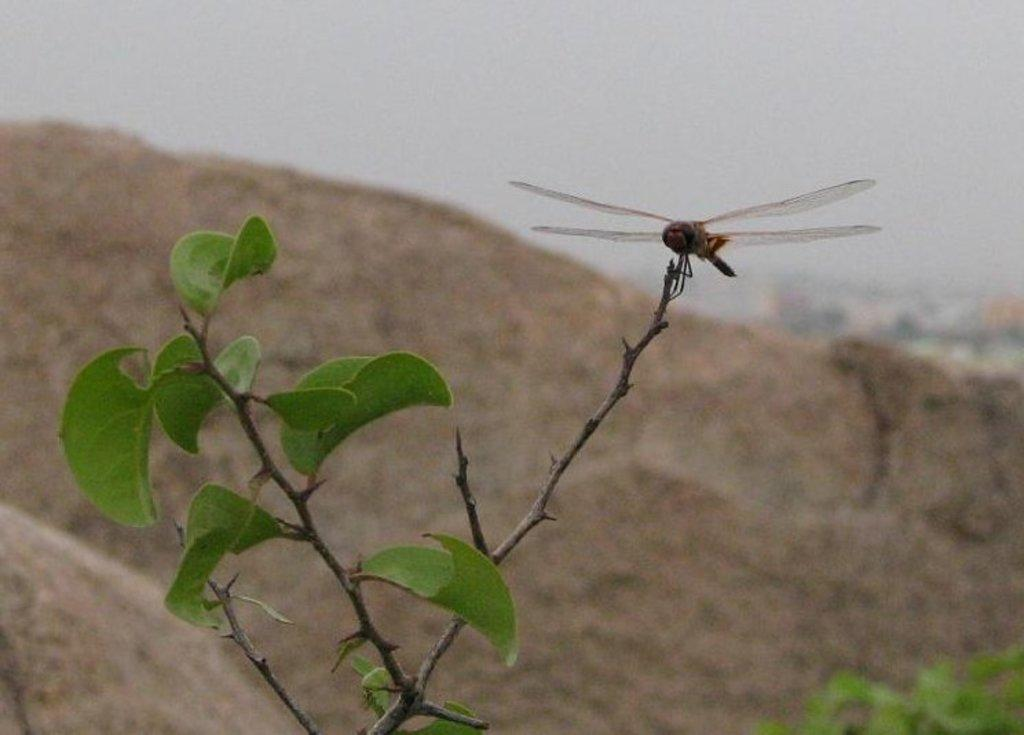What is present on the plant in the image? There is an insect on a plant in the image. What can be seen in the distance behind the plant? Mountains are visible in the background of the image. What else is visible in the background of the image? The sky is visible in the background of the image. What type of activity is the sink performing in the image? There is no sink present in the image, so it cannot be performing any activity. 